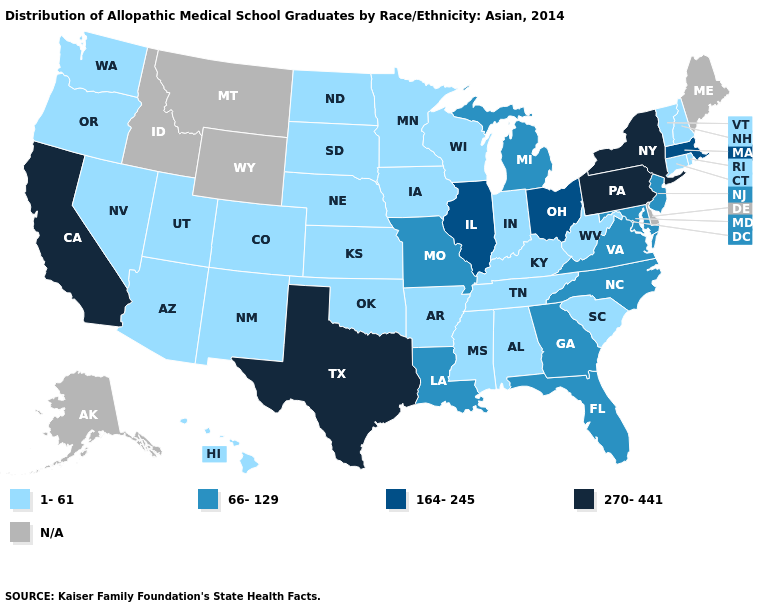What is the lowest value in the USA?
Short answer required. 1-61. Name the states that have a value in the range 1-61?
Write a very short answer. Alabama, Arizona, Arkansas, Colorado, Connecticut, Hawaii, Indiana, Iowa, Kansas, Kentucky, Minnesota, Mississippi, Nebraska, Nevada, New Hampshire, New Mexico, North Dakota, Oklahoma, Oregon, Rhode Island, South Carolina, South Dakota, Tennessee, Utah, Vermont, Washington, West Virginia, Wisconsin. Is the legend a continuous bar?
Answer briefly. No. Does Hawaii have the highest value in the USA?
Write a very short answer. No. Does Alabama have the lowest value in the USA?
Write a very short answer. Yes. What is the lowest value in the MidWest?
Keep it brief. 1-61. Does the first symbol in the legend represent the smallest category?
Give a very brief answer. Yes. What is the value of Maine?
Keep it brief. N/A. What is the lowest value in the USA?
Keep it brief. 1-61. What is the value of Maryland?
Quick response, please. 66-129. How many symbols are there in the legend?
Answer briefly. 5. What is the value of Rhode Island?
Quick response, please. 1-61. Does New York have the highest value in the Northeast?
Concise answer only. Yes. 